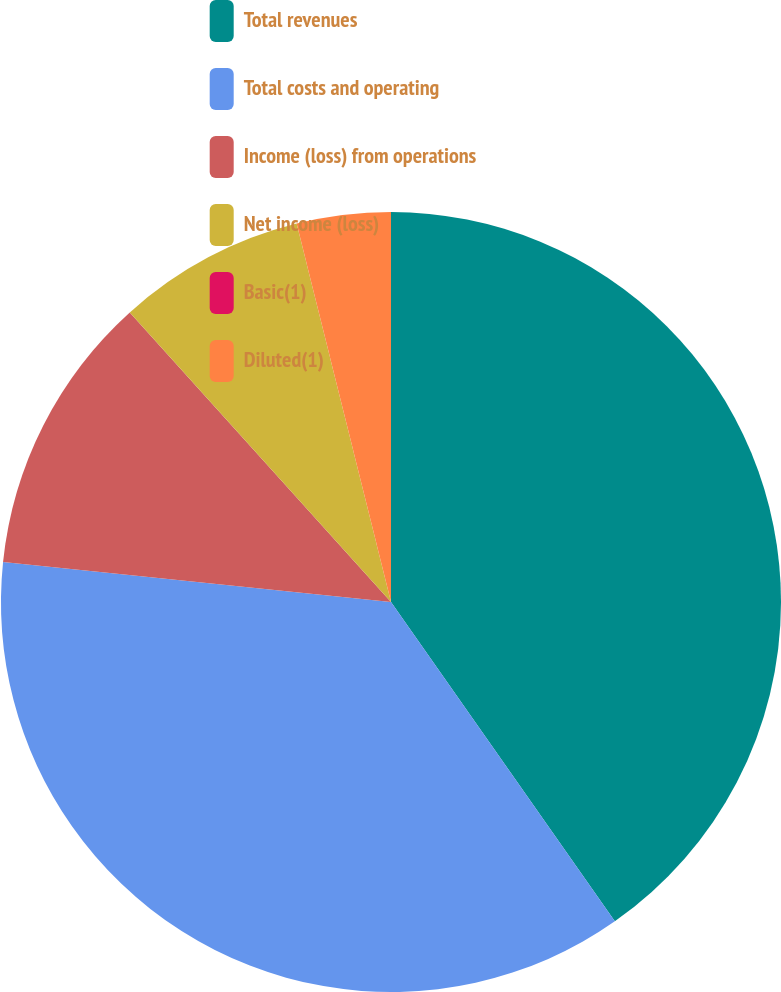<chart> <loc_0><loc_0><loc_500><loc_500><pie_chart><fcel>Total revenues<fcel>Total costs and operating<fcel>Income (loss) from operations<fcel>Net income (loss)<fcel>Basic(1)<fcel>Diluted(1)<nl><fcel>40.27%<fcel>36.37%<fcel>11.68%<fcel>7.79%<fcel>0.0%<fcel>3.89%<nl></chart> 